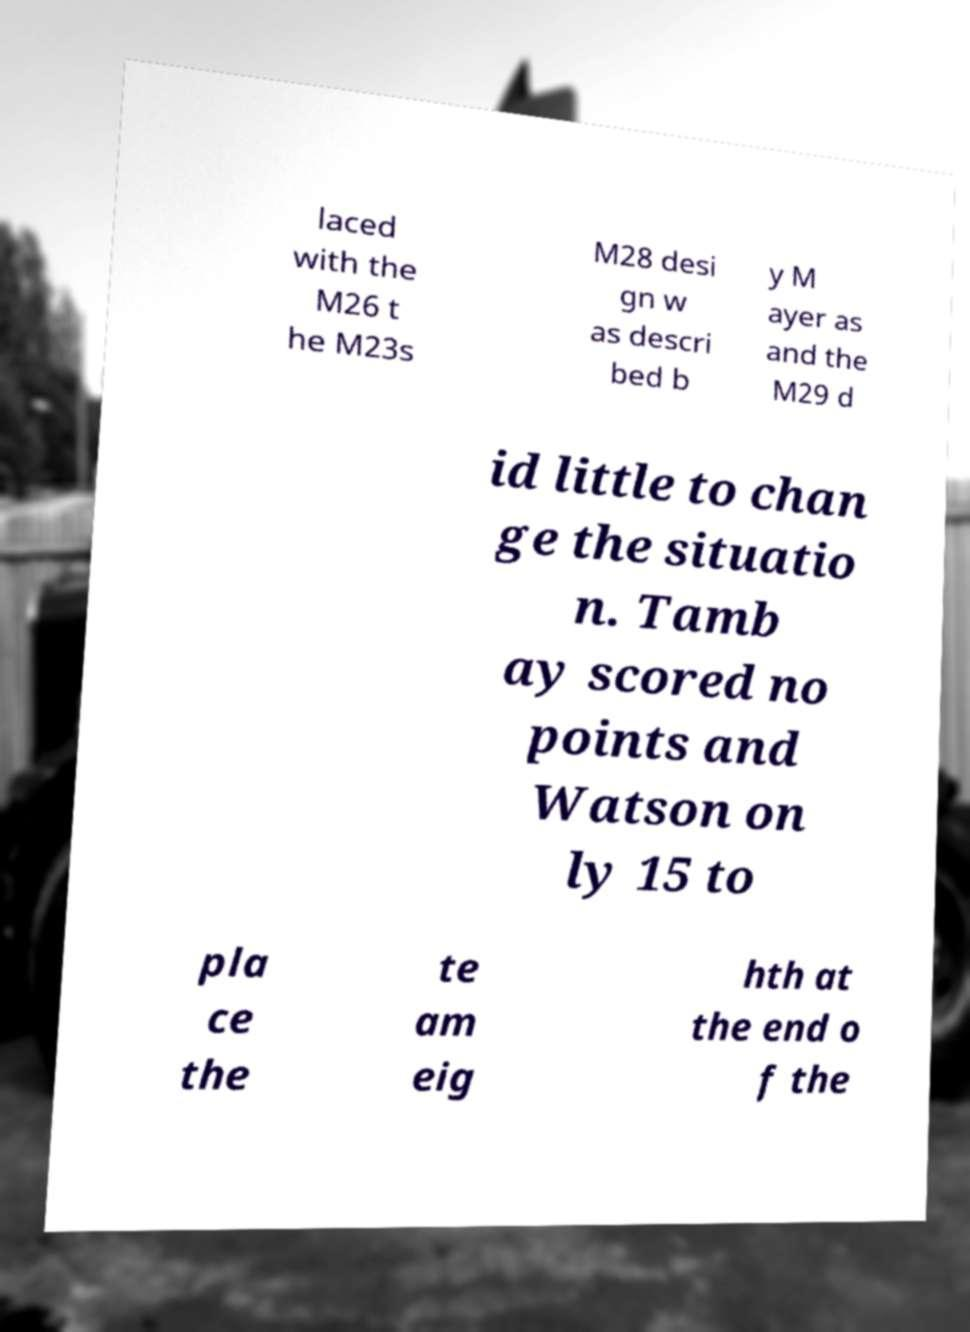Can you read and provide the text displayed in the image?This photo seems to have some interesting text. Can you extract and type it out for me? laced with the M26 t he M23s M28 desi gn w as descri bed b y M ayer as and the M29 d id little to chan ge the situatio n. Tamb ay scored no points and Watson on ly 15 to pla ce the te am eig hth at the end o f the 